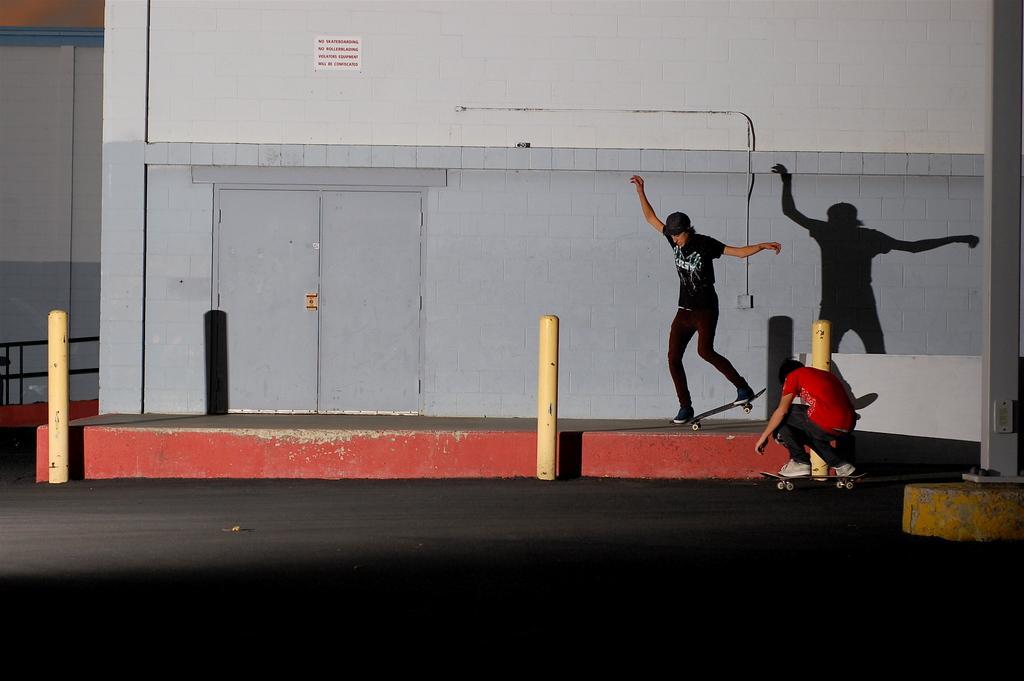Please provide a concise description of this image. In this image I can see two people with the skateboards. These people are wearing the different color dresses I can see one person with the cap. I can see the poles and there is a paper to the wall. 